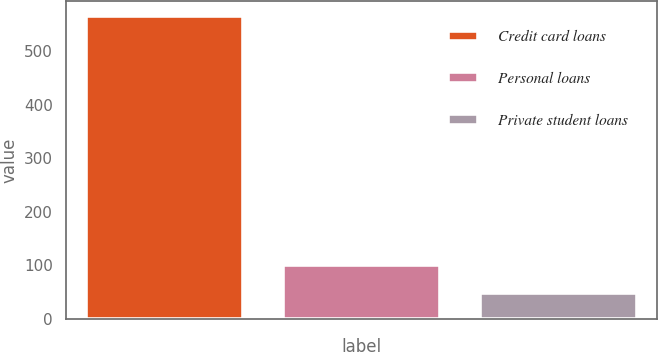Convert chart to OTSL. <chart><loc_0><loc_0><loc_500><loc_500><bar_chart><fcel>Credit card loans<fcel>Personal loans<fcel>Private student loans<nl><fcel>565<fcel>100.6<fcel>49<nl></chart> 